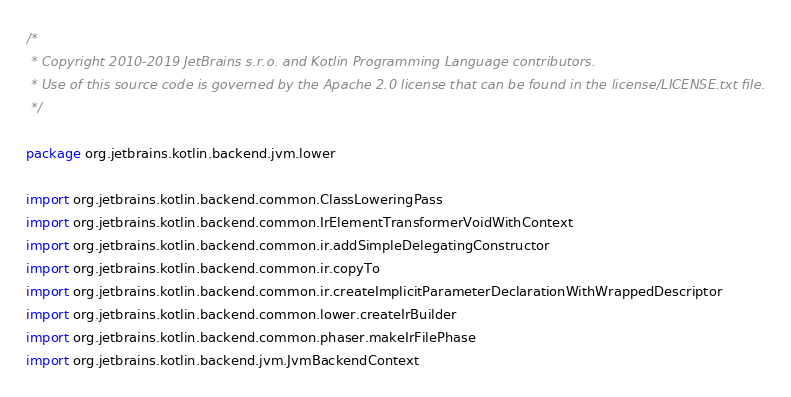Convert code to text. <code><loc_0><loc_0><loc_500><loc_500><_Kotlin_>/*
 * Copyright 2010-2019 JetBrains s.r.o. and Kotlin Programming Language contributors.
 * Use of this source code is governed by the Apache 2.0 license that can be found in the license/LICENSE.txt file.
 */

package org.jetbrains.kotlin.backend.jvm.lower

import org.jetbrains.kotlin.backend.common.ClassLoweringPass
import org.jetbrains.kotlin.backend.common.IrElementTransformerVoidWithContext
import org.jetbrains.kotlin.backend.common.ir.addSimpleDelegatingConstructor
import org.jetbrains.kotlin.backend.common.ir.copyTo
import org.jetbrains.kotlin.backend.common.ir.createImplicitParameterDeclarationWithWrappedDescriptor
import org.jetbrains.kotlin.backend.common.lower.createIrBuilder
import org.jetbrains.kotlin.backend.common.phaser.makeIrFilePhase
import org.jetbrains.kotlin.backend.jvm.JvmBackendContext</code> 